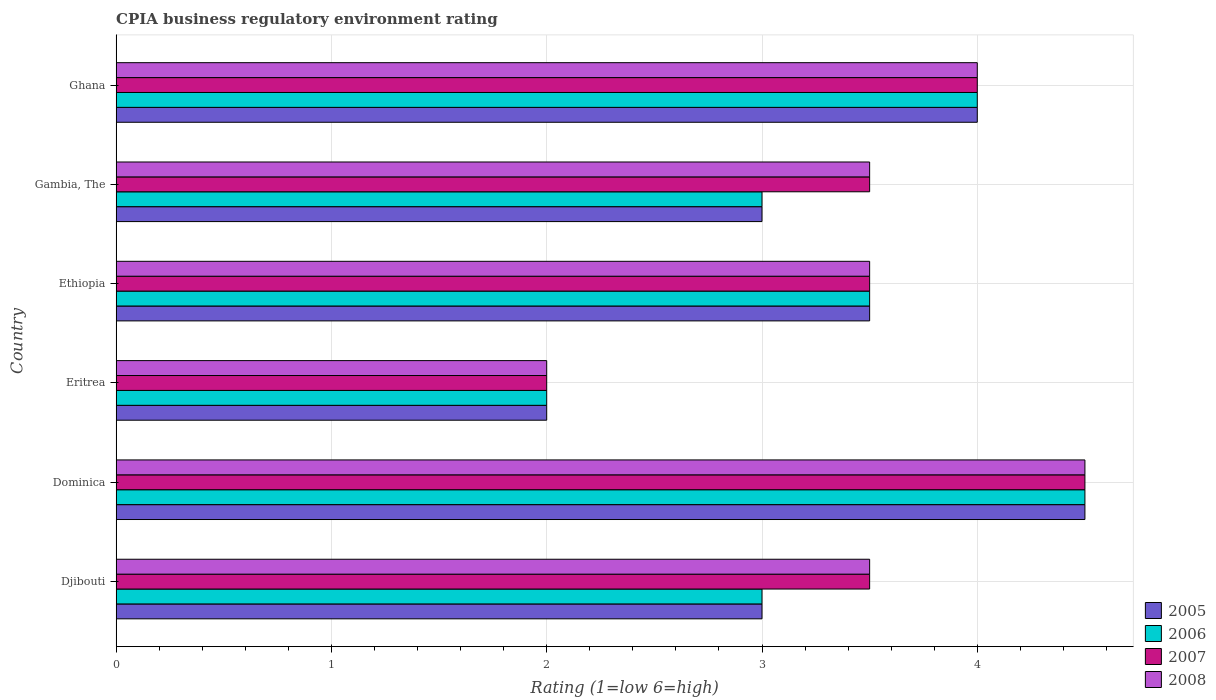Are the number of bars per tick equal to the number of legend labels?
Provide a succinct answer. Yes. How many bars are there on the 3rd tick from the top?
Keep it short and to the point. 4. How many bars are there on the 3rd tick from the bottom?
Give a very brief answer. 4. What is the label of the 1st group of bars from the top?
Make the answer very short. Ghana. In how many cases, is the number of bars for a given country not equal to the number of legend labels?
Make the answer very short. 0. Across all countries, what is the maximum CPIA rating in 2006?
Your answer should be very brief. 4.5. Across all countries, what is the minimum CPIA rating in 2007?
Make the answer very short. 2. In which country was the CPIA rating in 2005 maximum?
Your answer should be compact. Dominica. In which country was the CPIA rating in 2006 minimum?
Your answer should be very brief. Eritrea. What is the total CPIA rating in 2006 in the graph?
Your answer should be compact. 20. What is the difference between the CPIA rating in 2005 in Dominica and that in Ethiopia?
Your answer should be compact. 1. What is the difference between the CPIA rating in 2006 in Eritrea and the CPIA rating in 2007 in Djibouti?
Keep it short and to the point. -1.5. What is the average CPIA rating in 2007 per country?
Provide a short and direct response. 3.5. What is the difference between the CPIA rating in 2005 and CPIA rating in 2007 in Ethiopia?
Make the answer very short. 0. What is the ratio of the CPIA rating in 2008 in Dominica to that in Eritrea?
Provide a succinct answer. 2.25. What is the difference between the highest and the second highest CPIA rating in 2006?
Offer a terse response. 0.5. In how many countries, is the CPIA rating in 2008 greater than the average CPIA rating in 2008 taken over all countries?
Keep it short and to the point. 2. Is the sum of the CPIA rating in 2008 in Ethiopia and Ghana greater than the maximum CPIA rating in 2007 across all countries?
Offer a terse response. Yes. Is it the case that in every country, the sum of the CPIA rating in 2007 and CPIA rating in 2005 is greater than the sum of CPIA rating in 2008 and CPIA rating in 2006?
Your response must be concise. No. How many bars are there?
Provide a short and direct response. 24. Are all the bars in the graph horizontal?
Keep it short and to the point. Yes. How many countries are there in the graph?
Give a very brief answer. 6. Does the graph contain grids?
Provide a succinct answer. Yes. How are the legend labels stacked?
Make the answer very short. Vertical. What is the title of the graph?
Keep it short and to the point. CPIA business regulatory environment rating. Does "1975" appear as one of the legend labels in the graph?
Offer a terse response. No. What is the label or title of the X-axis?
Your response must be concise. Rating (1=low 6=high). What is the label or title of the Y-axis?
Give a very brief answer. Country. What is the Rating (1=low 6=high) of 2006 in Djibouti?
Provide a succinct answer. 3. What is the Rating (1=low 6=high) of 2008 in Djibouti?
Your answer should be compact. 3.5. What is the Rating (1=low 6=high) of 2005 in Dominica?
Keep it short and to the point. 4.5. What is the Rating (1=low 6=high) in 2005 in Eritrea?
Give a very brief answer. 2. What is the Rating (1=low 6=high) in 2007 in Ethiopia?
Your answer should be compact. 3.5. What is the Rating (1=low 6=high) in 2005 in Gambia, The?
Give a very brief answer. 3. What is the Rating (1=low 6=high) of 2006 in Ghana?
Offer a terse response. 4. What is the Rating (1=low 6=high) of 2007 in Ghana?
Offer a very short reply. 4. What is the Rating (1=low 6=high) in 2008 in Ghana?
Provide a short and direct response. 4. Across all countries, what is the maximum Rating (1=low 6=high) of 2006?
Ensure brevity in your answer.  4.5. Across all countries, what is the maximum Rating (1=low 6=high) in 2008?
Ensure brevity in your answer.  4.5. Across all countries, what is the minimum Rating (1=low 6=high) of 2008?
Your answer should be compact. 2. What is the total Rating (1=low 6=high) of 2006 in the graph?
Provide a short and direct response. 20. What is the total Rating (1=low 6=high) in 2007 in the graph?
Keep it short and to the point. 21. What is the total Rating (1=low 6=high) in 2008 in the graph?
Give a very brief answer. 21. What is the difference between the Rating (1=low 6=high) of 2005 in Djibouti and that in Dominica?
Ensure brevity in your answer.  -1.5. What is the difference between the Rating (1=low 6=high) of 2007 in Djibouti and that in Dominica?
Offer a very short reply. -1. What is the difference between the Rating (1=low 6=high) of 2005 in Djibouti and that in Eritrea?
Give a very brief answer. 1. What is the difference between the Rating (1=low 6=high) of 2008 in Djibouti and that in Eritrea?
Your answer should be compact. 1.5. What is the difference between the Rating (1=low 6=high) in 2005 in Djibouti and that in Ethiopia?
Your answer should be compact. -0.5. What is the difference between the Rating (1=low 6=high) of 2006 in Djibouti and that in Ethiopia?
Ensure brevity in your answer.  -0.5. What is the difference between the Rating (1=low 6=high) of 2007 in Djibouti and that in Ethiopia?
Your answer should be compact. 0. What is the difference between the Rating (1=low 6=high) of 2008 in Djibouti and that in Ethiopia?
Give a very brief answer. 0. What is the difference between the Rating (1=low 6=high) of 2005 in Djibouti and that in Gambia, The?
Your answer should be compact. 0. What is the difference between the Rating (1=low 6=high) of 2006 in Djibouti and that in Gambia, The?
Your response must be concise. 0. What is the difference between the Rating (1=low 6=high) in 2007 in Djibouti and that in Gambia, The?
Your answer should be compact. 0. What is the difference between the Rating (1=low 6=high) of 2008 in Djibouti and that in Gambia, The?
Your answer should be compact. 0. What is the difference between the Rating (1=low 6=high) of 2005 in Djibouti and that in Ghana?
Your response must be concise. -1. What is the difference between the Rating (1=low 6=high) in 2008 in Djibouti and that in Ghana?
Give a very brief answer. -0.5. What is the difference between the Rating (1=low 6=high) of 2008 in Dominica and that in Eritrea?
Offer a terse response. 2.5. What is the difference between the Rating (1=low 6=high) in 2005 in Dominica and that in Ethiopia?
Keep it short and to the point. 1. What is the difference between the Rating (1=low 6=high) in 2007 in Dominica and that in Ethiopia?
Make the answer very short. 1. What is the difference between the Rating (1=low 6=high) of 2008 in Dominica and that in Ethiopia?
Make the answer very short. 1. What is the difference between the Rating (1=low 6=high) in 2005 in Dominica and that in Gambia, The?
Your answer should be compact. 1.5. What is the difference between the Rating (1=low 6=high) in 2007 in Dominica and that in Gambia, The?
Ensure brevity in your answer.  1. What is the difference between the Rating (1=low 6=high) of 2005 in Dominica and that in Ghana?
Provide a short and direct response. 0.5. What is the difference between the Rating (1=low 6=high) in 2007 in Dominica and that in Ghana?
Give a very brief answer. 0.5. What is the difference between the Rating (1=low 6=high) in 2008 in Dominica and that in Ghana?
Offer a very short reply. 0.5. What is the difference between the Rating (1=low 6=high) in 2006 in Eritrea and that in Gambia, The?
Your response must be concise. -1. What is the difference between the Rating (1=low 6=high) in 2005 in Eritrea and that in Ghana?
Offer a terse response. -2. What is the difference between the Rating (1=low 6=high) in 2008 in Eritrea and that in Ghana?
Keep it short and to the point. -2. What is the difference between the Rating (1=low 6=high) in 2008 in Ethiopia and that in Ghana?
Your response must be concise. -0.5. What is the difference between the Rating (1=low 6=high) of 2006 in Gambia, The and that in Ghana?
Give a very brief answer. -1. What is the difference between the Rating (1=low 6=high) of 2007 in Gambia, The and that in Ghana?
Ensure brevity in your answer.  -0.5. What is the difference between the Rating (1=low 6=high) of 2008 in Gambia, The and that in Ghana?
Keep it short and to the point. -0.5. What is the difference between the Rating (1=low 6=high) of 2005 in Djibouti and the Rating (1=low 6=high) of 2006 in Dominica?
Make the answer very short. -1.5. What is the difference between the Rating (1=low 6=high) in 2005 in Djibouti and the Rating (1=low 6=high) in 2007 in Dominica?
Offer a terse response. -1.5. What is the difference between the Rating (1=low 6=high) of 2005 in Djibouti and the Rating (1=low 6=high) of 2008 in Dominica?
Your response must be concise. -1.5. What is the difference between the Rating (1=low 6=high) in 2006 in Djibouti and the Rating (1=low 6=high) in 2008 in Dominica?
Provide a succinct answer. -1.5. What is the difference between the Rating (1=low 6=high) of 2007 in Djibouti and the Rating (1=low 6=high) of 2008 in Dominica?
Your answer should be very brief. -1. What is the difference between the Rating (1=low 6=high) in 2005 in Djibouti and the Rating (1=low 6=high) in 2006 in Eritrea?
Give a very brief answer. 1. What is the difference between the Rating (1=low 6=high) of 2006 in Djibouti and the Rating (1=low 6=high) of 2008 in Eritrea?
Provide a succinct answer. 1. What is the difference between the Rating (1=low 6=high) in 2005 in Djibouti and the Rating (1=low 6=high) in 2006 in Ethiopia?
Offer a very short reply. -0.5. What is the difference between the Rating (1=low 6=high) of 2005 in Djibouti and the Rating (1=low 6=high) of 2007 in Ethiopia?
Provide a succinct answer. -0.5. What is the difference between the Rating (1=low 6=high) in 2006 in Djibouti and the Rating (1=low 6=high) in 2007 in Ethiopia?
Provide a short and direct response. -0.5. What is the difference between the Rating (1=low 6=high) in 2006 in Djibouti and the Rating (1=low 6=high) in 2008 in Ethiopia?
Give a very brief answer. -0.5. What is the difference between the Rating (1=low 6=high) in 2005 in Djibouti and the Rating (1=low 6=high) in 2007 in Gambia, The?
Provide a short and direct response. -0.5. What is the difference between the Rating (1=low 6=high) in 2006 in Djibouti and the Rating (1=low 6=high) in 2007 in Gambia, The?
Your answer should be very brief. -0.5. What is the difference between the Rating (1=low 6=high) of 2007 in Djibouti and the Rating (1=low 6=high) of 2008 in Gambia, The?
Offer a terse response. 0. What is the difference between the Rating (1=low 6=high) in 2006 in Djibouti and the Rating (1=low 6=high) in 2008 in Ghana?
Provide a succinct answer. -1. What is the difference between the Rating (1=low 6=high) of 2007 in Djibouti and the Rating (1=low 6=high) of 2008 in Ghana?
Provide a short and direct response. -0.5. What is the difference between the Rating (1=low 6=high) in 2005 in Dominica and the Rating (1=low 6=high) in 2006 in Eritrea?
Offer a terse response. 2.5. What is the difference between the Rating (1=low 6=high) in 2005 in Dominica and the Rating (1=low 6=high) in 2007 in Eritrea?
Give a very brief answer. 2.5. What is the difference between the Rating (1=low 6=high) of 2006 in Dominica and the Rating (1=low 6=high) of 2007 in Eritrea?
Make the answer very short. 2.5. What is the difference between the Rating (1=low 6=high) of 2006 in Dominica and the Rating (1=low 6=high) of 2008 in Eritrea?
Your answer should be very brief. 2.5. What is the difference between the Rating (1=low 6=high) in 2005 in Dominica and the Rating (1=low 6=high) in 2006 in Ethiopia?
Provide a short and direct response. 1. What is the difference between the Rating (1=low 6=high) in 2005 in Dominica and the Rating (1=low 6=high) in 2007 in Ethiopia?
Make the answer very short. 1. What is the difference between the Rating (1=low 6=high) of 2005 in Dominica and the Rating (1=low 6=high) of 2008 in Ethiopia?
Your answer should be compact. 1. What is the difference between the Rating (1=low 6=high) of 2006 in Dominica and the Rating (1=low 6=high) of 2007 in Ethiopia?
Ensure brevity in your answer.  1. What is the difference between the Rating (1=low 6=high) of 2006 in Dominica and the Rating (1=low 6=high) of 2008 in Ethiopia?
Your response must be concise. 1. What is the difference between the Rating (1=low 6=high) in 2005 in Dominica and the Rating (1=low 6=high) in 2006 in Gambia, The?
Make the answer very short. 1.5. What is the difference between the Rating (1=low 6=high) of 2005 in Dominica and the Rating (1=low 6=high) of 2007 in Gambia, The?
Your answer should be very brief. 1. What is the difference between the Rating (1=low 6=high) in 2006 in Dominica and the Rating (1=low 6=high) in 2007 in Gambia, The?
Your answer should be very brief. 1. What is the difference between the Rating (1=low 6=high) in 2006 in Dominica and the Rating (1=low 6=high) in 2007 in Ghana?
Ensure brevity in your answer.  0.5. What is the difference between the Rating (1=low 6=high) in 2006 in Dominica and the Rating (1=low 6=high) in 2008 in Ghana?
Give a very brief answer. 0.5. What is the difference between the Rating (1=low 6=high) in 2005 in Eritrea and the Rating (1=low 6=high) in 2006 in Ethiopia?
Keep it short and to the point. -1.5. What is the difference between the Rating (1=low 6=high) of 2005 in Eritrea and the Rating (1=low 6=high) of 2007 in Ethiopia?
Your answer should be very brief. -1.5. What is the difference between the Rating (1=low 6=high) in 2007 in Eritrea and the Rating (1=low 6=high) in 2008 in Ethiopia?
Make the answer very short. -1.5. What is the difference between the Rating (1=low 6=high) of 2006 in Eritrea and the Rating (1=low 6=high) of 2007 in Gambia, The?
Provide a short and direct response. -1.5. What is the difference between the Rating (1=low 6=high) in 2006 in Eritrea and the Rating (1=low 6=high) in 2008 in Gambia, The?
Your answer should be compact. -1.5. What is the difference between the Rating (1=low 6=high) of 2007 in Eritrea and the Rating (1=low 6=high) of 2008 in Gambia, The?
Offer a terse response. -1.5. What is the difference between the Rating (1=low 6=high) in 2005 in Eritrea and the Rating (1=low 6=high) in 2008 in Ghana?
Ensure brevity in your answer.  -2. What is the difference between the Rating (1=low 6=high) in 2006 in Ethiopia and the Rating (1=low 6=high) in 2008 in Gambia, The?
Your answer should be very brief. 0. What is the difference between the Rating (1=low 6=high) of 2007 in Ethiopia and the Rating (1=low 6=high) of 2008 in Gambia, The?
Your answer should be very brief. 0. What is the difference between the Rating (1=low 6=high) of 2005 in Ethiopia and the Rating (1=low 6=high) of 2006 in Ghana?
Your answer should be compact. -0.5. What is the difference between the Rating (1=low 6=high) in 2005 in Ethiopia and the Rating (1=low 6=high) in 2008 in Ghana?
Make the answer very short. -0.5. What is the difference between the Rating (1=low 6=high) of 2005 in Gambia, The and the Rating (1=low 6=high) of 2007 in Ghana?
Make the answer very short. -1. What is the difference between the Rating (1=low 6=high) of 2006 in Gambia, The and the Rating (1=low 6=high) of 2007 in Ghana?
Make the answer very short. -1. What is the average Rating (1=low 6=high) of 2005 per country?
Your response must be concise. 3.33. What is the average Rating (1=low 6=high) of 2006 per country?
Offer a terse response. 3.33. What is the average Rating (1=low 6=high) in 2007 per country?
Provide a succinct answer. 3.5. What is the average Rating (1=low 6=high) in 2008 per country?
Your answer should be very brief. 3.5. What is the difference between the Rating (1=low 6=high) in 2005 and Rating (1=low 6=high) in 2008 in Djibouti?
Your answer should be compact. -0.5. What is the difference between the Rating (1=low 6=high) of 2006 and Rating (1=low 6=high) of 2007 in Djibouti?
Ensure brevity in your answer.  -0.5. What is the difference between the Rating (1=low 6=high) in 2005 and Rating (1=low 6=high) in 2006 in Dominica?
Give a very brief answer. 0. What is the difference between the Rating (1=low 6=high) in 2006 and Rating (1=low 6=high) in 2007 in Dominica?
Your answer should be very brief. 0. What is the difference between the Rating (1=low 6=high) in 2006 and Rating (1=low 6=high) in 2008 in Dominica?
Offer a terse response. 0. What is the difference between the Rating (1=low 6=high) in 2005 and Rating (1=low 6=high) in 2006 in Eritrea?
Your answer should be compact. 0. What is the difference between the Rating (1=low 6=high) of 2005 and Rating (1=low 6=high) of 2007 in Eritrea?
Your answer should be compact. 0. What is the difference between the Rating (1=low 6=high) of 2007 and Rating (1=low 6=high) of 2008 in Eritrea?
Give a very brief answer. 0. What is the difference between the Rating (1=low 6=high) in 2005 and Rating (1=low 6=high) in 2006 in Ethiopia?
Provide a succinct answer. 0. What is the difference between the Rating (1=low 6=high) in 2006 and Rating (1=low 6=high) in 2007 in Ethiopia?
Ensure brevity in your answer.  0. What is the difference between the Rating (1=low 6=high) in 2006 and Rating (1=low 6=high) in 2008 in Ethiopia?
Your response must be concise. 0. What is the difference between the Rating (1=low 6=high) in 2005 and Rating (1=low 6=high) in 2008 in Gambia, The?
Your answer should be compact. -0.5. What is the difference between the Rating (1=low 6=high) of 2006 and Rating (1=low 6=high) of 2008 in Gambia, The?
Keep it short and to the point. -0.5. What is the difference between the Rating (1=low 6=high) in 2007 and Rating (1=low 6=high) in 2008 in Gambia, The?
Provide a succinct answer. 0. What is the difference between the Rating (1=low 6=high) in 2005 and Rating (1=low 6=high) in 2006 in Ghana?
Your response must be concise. 0. What is the difference between the Rating (1=low 6=high) in 2006 and Rating (1=low 6=high) in 2008 in Ghana?
Give a very brief answer. 0. What is the difference between the Rating (1=low 6=high) in 2007 and Rating (1=low 6=high) in 2008 in Ghana?
Your answer should be very brief. 0. What is the ratio of the Rating (1=low 6=high) of 2006 in Djibouti to that in Dominica?
Provide a short and direct response. 0.67. What is the ratio of the Rating (1=low 6=high) of 2008 in Djibouti to that in Dominica?
Give a very brief answer. 0.78. What is the ratio of the Rating (1=low 6=high) of 2005 in Djibouti to that in Eritrea?
Give a very brief answer. 1.5. What is the ratio of the Rating (1=low 6=high) of 2006 in Djibouti to that in Eritrea?
Keep it short and to the point. 1.5. What is the ratio of the Rating (1=low 6=high) in 2008 in Djibouti to that in Eritrea?
Give a very brief answer. 1.75. What is the ratio of the Rating (1=low 6=high) of 2005 in Djibouti to that in Ethiopia?
Your response must be concise. 0.86. What is the ratio of the Rating (1=low 6=high) of 2006 in Djibouti to that in Ethiopia?
Your answer should be very brief. 0.86. What is the ratio of the Rating (1=low 6=high) in 2007 in Djibouti to that in Ethiopia?
Provide a short and direct response. 1. What is the ratio of the Rating (1=low 6=high) of 2008 in Djibouti to that in Ethiopia?
Your response must be concise. 1. What is the ratio of the Rating (1=low 6=high) in 2006 in Djibouti to that in Gambia, The?
Your answer should be very brief. 1. What is the ratio of the Rating (1=low 6=high) in 2007 in Djibouti to that in Gambia, The?
Give a very brief answer. 1. What is the ratio of the Rating (1=low 6=high) of 2006 in Djibouti to that in Ghana?
Give a very brief answer. 0.75. What is the ratio of the Rating (1=low 6=high) of 2005 in Dominica to that in Eritrea?
Make the answer very short. 2.25. What is the ratio of the Rating (1=low 6=high) in 2006 in Dominica to that in Eritrea?
Give a very brief answer. 2.25. What is the ratio of the Rating (1=low 6=high) in 2007 in Dominica to that in Eritrea?
Offer a very short reply. 2.25. What is the ratio of the Rating (1=low 6=high) in 2008 in Dominica to that in Eritrea?
Your response must be concise. 2.25. What is the ratio of the Rating (1=low 6=high) of 2005 in Dominica to that in Ethiopia?
Keep it short and to the point. 1.29. What is the ratio of the Rating (1=low 6=high) of 2007 in Dominica to that in Ethiopia?
Make the answer very short. 1.29. What is the ratio of the Rating (1=low 6=high) of 2008 in Dominica to that in Ethiopia?
Give a very brief answer. 1.29. What is the ratio of the Rating (1=low 6=high) of 2007 in Dominica to that in Gambia, The?
Make the answer very short. 1.29. What is the ratio of the Rating (1=low 6=high) in 2005 in Dominica to that in Ghana?
Provide a succinct answer. 1.12. What is the ratio of the Rating (1=low 6=high) of 2006 in Dominica to that in Ghana?
Your answer should be very brief. 1.12. What is the ratio of the Rating (1=low 6=high) of 2007 in Eritrea to that in Ethiopia?
Offer a terse response. 0.57. What is the ratio of the Rating (1=low 6=high) of 2006 in Eritrea to that in Gambia, The?
Provide a succinct answer. 0.67. What is the ratio of the Rating (1=low 6=high) in 2006 in Eritrea to that in Ghana?
Ensure brevity in your answer.  0.5. What is the ratio of the Rating (1=low 6=high) in 2007 in Eritrea to that in Ghana?
Offer a terse response. 0.5. What is the ratio of the Rating (1=low 6=high) in 2005 in Ethiopia to that in Gambia, The?
Your response must be concise. 1.17. What is the ratio of the Rating (1=low 6=high) of 2007 in Ethiopia to that in Gambia, The?
Offer a very short reply. 1. What is the ratio of the Rating (1=low 6=high) of 2008 in Ethiopia to that in Gambia, The?
Make the answer very short. 1. What is the ratio of the Rating (1=low 6=high) in 2005 in Ethiopia to that in Ghana?
Your answer should be compact. 0.88. What is the ratio of the Rating (1=low 6=high) of 2007 in Ethiopia to that in Ghana?
Your answer should be compact. 0.88. What is the ratio of the Rating (1=low 6=high) in 2008 in Ethiopia to that in Ghana?
Your answer should be compact. 0.88. What is the ratio of the Rating (1=low 6=high) of 2005 in Gambia, The to that in Ghana?
Give a very brief answer. 0.75. What is the difference between the highest and the second highest Rating (1=low 6=high) in 2005?
Keep it short and to the point. 0.5. What is the difference between the highest and the second highest Rating (1=low 6=high) in 2006?
Your response must be concise. 0.5. What is the difference between the highest and the second highest Rating (1=low 6=high) of 2008?
Keep it short and to the point. 0.5. What is the difference between the highest and the lowest Rating (1=low 6=high) in 2005?
Ensure brevity in your answer.  2.5. What is the difference between the highest and the lowest Rating (1=low 6=high) in 2006?
Ensure brevity in your answer.  2.5. What is the difference between the highest and the lowest Rating (1=low 6=high) of 2008?
Make the answer very short. 2.5. 